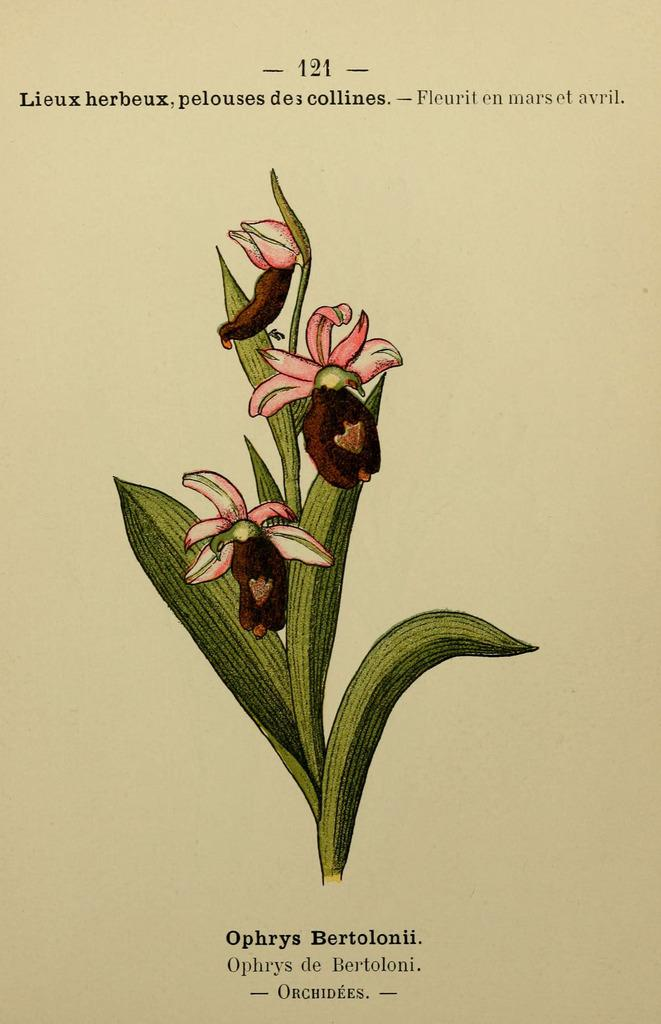What is the medium of the image? The image is a sketch on a paper. What is the main subject of the sketch? The sketch features a stem, leaves, and flowers in the center. Where are the flowers located in the image? The flowers are in the center of the image. What else can be seen in the background of the image? There is text in the background of the image. What type of fear can be seen in the image? There is no fear depicted in the image; it is a sketch of a stem, leaves, and flowers with text in the background. What color is the copper in the image? There is no copper present in the image. 